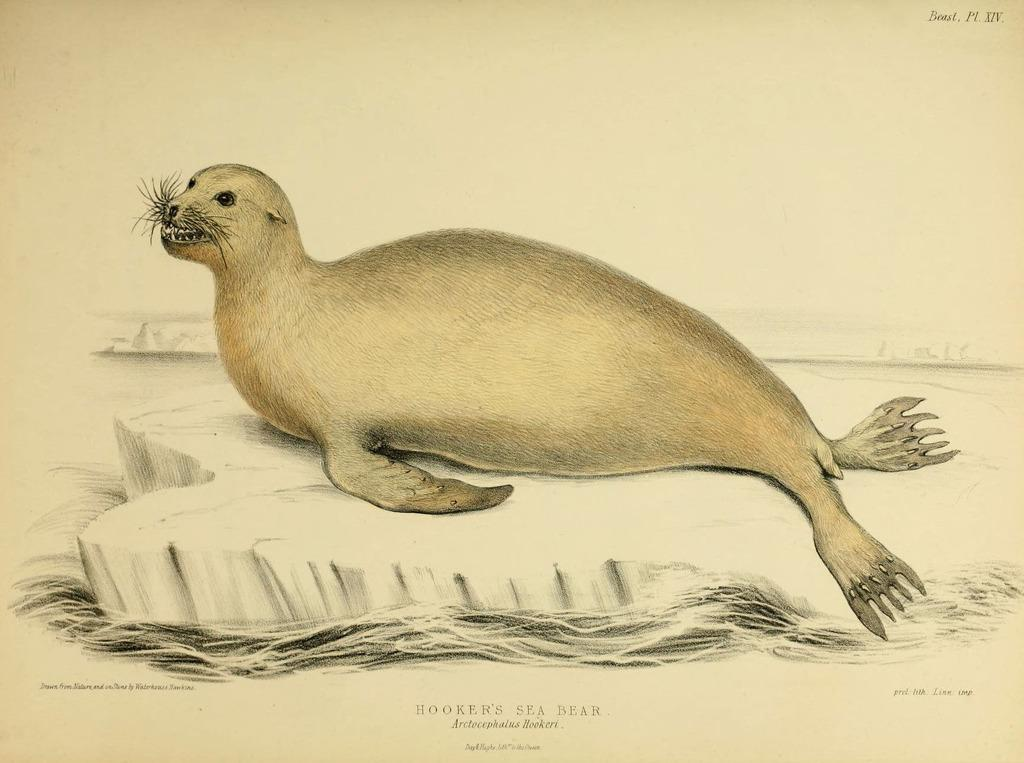What is the main subject of the drawing in the image? The main subject of the drawing in the image is a seal. What is the seal doing in the drawing? The seal is floating on an ice in the drawing. What can be seen on the top and bottom of the image? There is text written on the top and bottom of the image. How many toes can be seen on the seal in the image? Seals do not have toes, so there are none visible in the image. What type of offer is being made by the seal in the image? There is no offer being made by the seal in the image, as it is a drawing of a seal floating on an ice. 